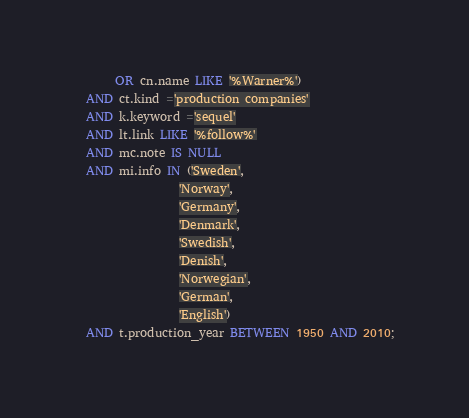Convert code to text. <code><loc_0><loc_0><loc_500><loc_500><_SQL_>       OR cn.name LIKE '%Warner%')
  AND ct.kind ='production companies'
  AND k.keyword ='sequel'
  AND lt.link LIKE '%follow%'
  AND mc.note IS NULL
  AND mi.info IN ('Sweden',
                  'Norway',
                  'Germany',
                  'Denmark',
                  'Swedish',
                  'Denish',
                  'Norwegian',
                  'German',
                  'English')
  AND t.production_year BETWEEN 1950 AND 2010;</code> 